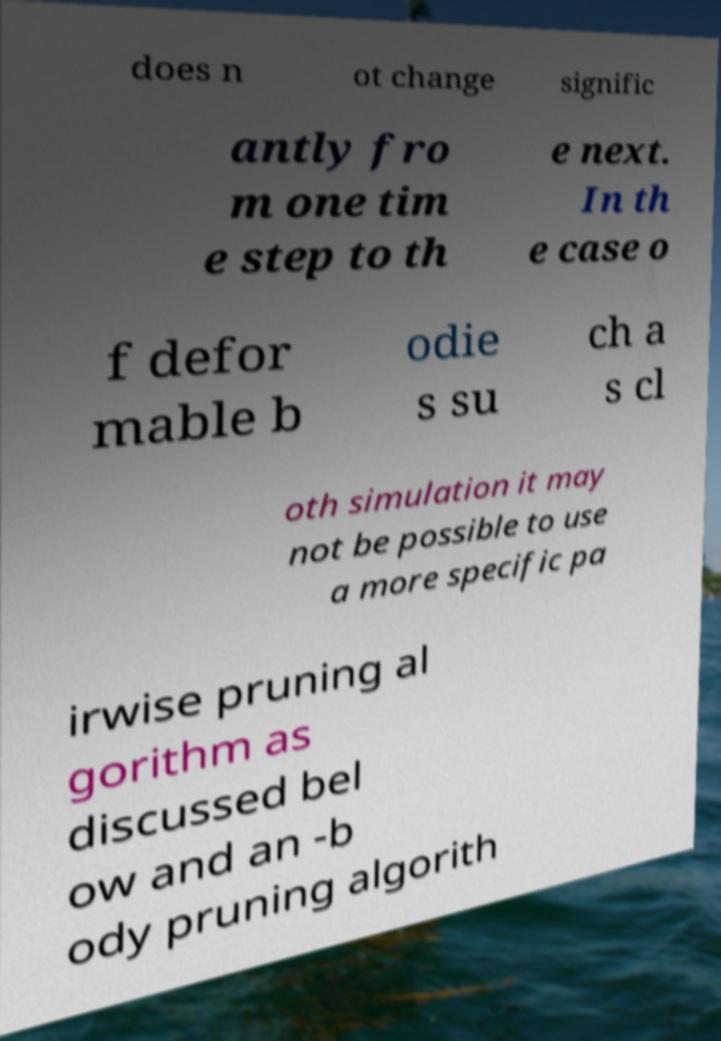What messages or text are displayed in this image? I need them in a readable, typed format. does n ot change signific antly fro m one tim e step to th e next. In th e case o f defor mable b odie s su ch a s cl oth simulation it may not be possible to use a more specific pa irwise pruning al gorithm as discussed bel ow and an -b ody pruning algorith 